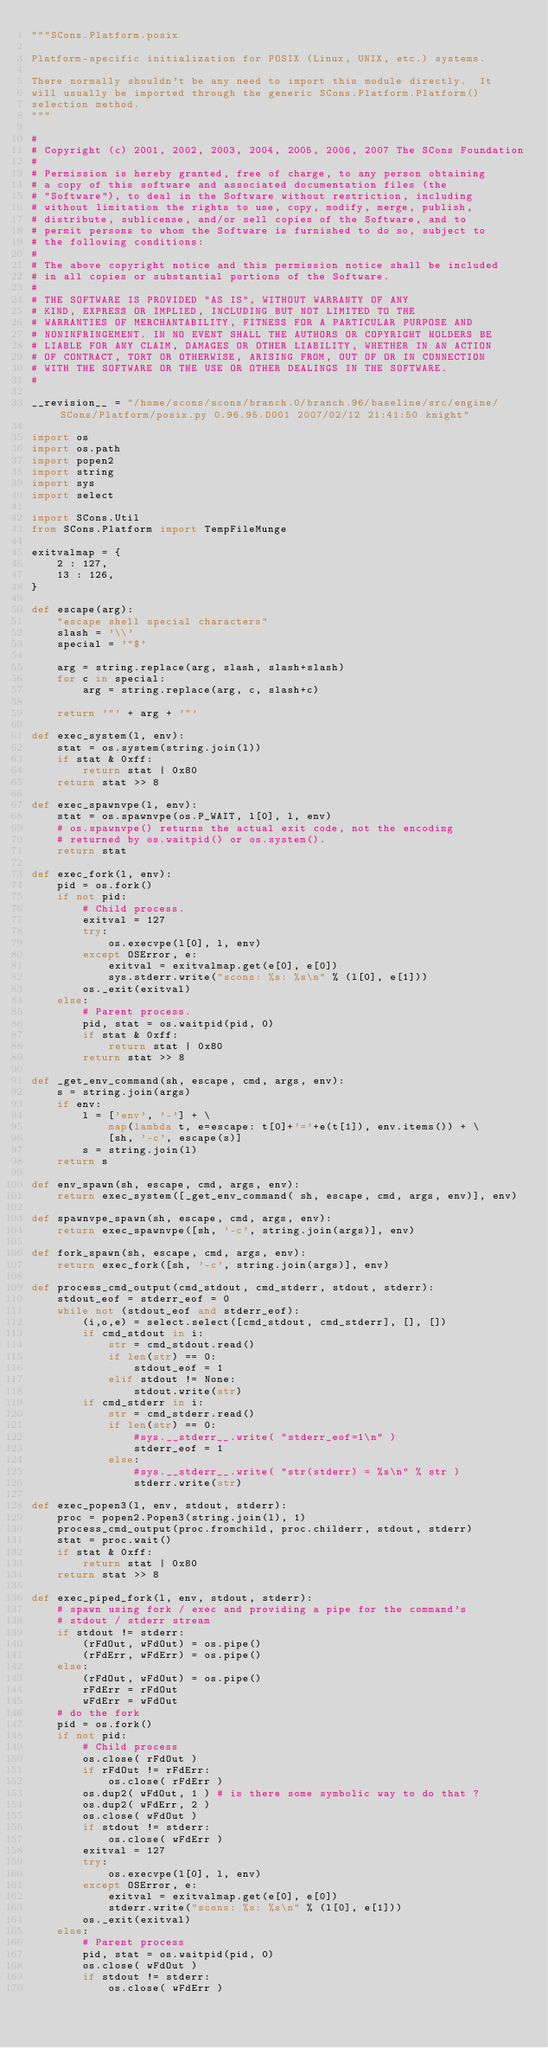<code> <loc_0><loc_0><loc_500><loc_500><_Python_>"""SCons.Platform.posix

Platform-specific initialization for POSIX (Linux, UNIX, etc.) systems.

There normally shouldn't be any need to import this module directly.  It
will usually be imported through the generic SCons.Platform.Platform()
selection method.
"""

#
# Copyright (c) 2001, 2002, 2003, 2004, 2005, 2006, 2007 The SCons Foundation
#
# Permission is hereby granted, free of charge, to any person obtaining
# a copy of this software and associated documentation files (the
# "Software"), to deal in the Software without restriction, including
# without limitation the rights to use, copy, modify, merge, publish,
# distribute, sublicense, and/or sell copies of the Software, and to
# permit persons to whom the Software is furnished to do so, subject to
# the following conditions:
#
# The above copyright notice and this permission notice shall be included
# in all copies or substantial portions of the Software.
#
# THE SOFTWARE IS PROVIDED "AS IS", WITHOUT WARRANTY OF ANY
# KIND, EXPRESS OR IMPLIED, INCLUDING BUT NOT LIMITED TO THE
# WARRANTIES OF MERCHANTABILITY, FITNESS FOR A PARTICULAR PURPOSE AND
# NONINFRINGEMENT. IN NO EVENT SHALL THE AUTHORS OR COPYRIGHT HOLDERS BE
# LIABLE FOR ANY CLAIM, DAMAGES OR OTHER LIABILITY, WHETHER IN AN ACTION
# OF CONTRACT, TORT OR OTHERWISE, ARISING FROM, OUT OF OR IN CONNECTION
# WITH THE SOFTWARE OR THE USE OR OTHER DEALINGS IN THE SOFTWARE.
#

__revision__ = "/home/scons/scons/branch.0/branch.96/baseline/src/engine/SCons/Platform/posix.py 0.96.95.D001 2007/02/12 21:41:50 knight"

import os
import os.path
import popen2
import string
import sys
import select

import SCons.Util
from SCons.Platform import TempFileMunge

exitvalmap = {
    2 : 127,
    13 : 126,
}

def escape(arg):
    "escape shell special characters"
    slash = '\\'
    special = '"$'

    arg = string.replace(arg, slash, slash+slash)
    for c in special:
        arg = string.replace(arg, c, slash+c)

    return '"' + arg + '"'

def exec_system(l, env):
    stat = os.system(string.join(l))
    if stat & 0xff:
        return stat | 0x80
    return stat >> 8

def exec_spawnvpe(l, env):
    stat = os.spawnvpe(os.P_WAIT, l[0], l, env)
    # os.spawnvpe() returns the actual exit code, not the encoding
    # returned by os.waitpid() or os.system().
    return stat

def exec_fork(l, env): 
    pid = os.fork()
    if not pid:
        # Child process.
        exitval = 127
        try:
            os.execvpe(l[0], l, env)
        except OSError, e:
            exitval = exitvalmap.get(e[0], e[0])
            sys.stderr.write("scons: %s: %s\n" % (l[0], e[1]))
        os._exit(exitval)
    else:
        # Parent process.
        pid, stat = os.waitpid(pid, 0)
        if stat & 0xff:
            return stat | 0x80
        return stat >> 8

def _get_env_command(sh, escape, cmd, args, env):
    s = string.join(args)
    if env:
        l = ['env', '-'] + \
            map(lambda t, e=escape: t[0]+'='+e(t[1]), env.items()) + \
            [sh, '-c', escape(s)]
        s = string.join(l)
    return s

def env_spawn(sh, escape, cmd, args, env):
    return exec_system([_get_env_command( sh, escape, cmd, args, env)], env)

def spawnvpe_spawn(sh, escape, cmd, args, env):
    return exec_spawnvpe([sh, '-c', string.join(args)], env)

def fork_spawn(sh, escape, cmd, args, env):
    return exec_fork([sh, '-c', string.join(args)], env)

def process_cmd_output(cmd_stdout, cmd_stderr, stdout, stderr):
    stdout_eof = stderr_eof = 0
    while not (stdout_eof and stderr_eof):
        (i,o,e) = select.select([cmd_stdout, cmd_stderr], [], [])
        if cmd_stdout in i:
            str = cmd_stdout.read()
            if len(str) == 0:
                stdout_eof = 1
            elif stdout != None:
                stdout.write(str)
        if cmd_stderr in i:
            str = cmd_stderr.read()
            if len(str) == 0:
                #sys.__stderr__.write( "stderr_eof=1\n" )
                stderr_eof = 1
            else:
                #sys.__stderr__.write( "str(stderr) = %s\n" % str )
                stderr.write(str)

def exec_popen3(l, env, stdout, stderr):
    proc = popen2.Popen3(string.join(l), 1)
    process_cmd_output(proc.fromchild, proc.childerr, stdout, stderr)
    stat = proc.wait()
    if stat & 0xff:
        return stat | 0x80
    return stat >> 8

def exec_piped_fork(l, env, stdout, stderr):
    # spawn using fork / exec and providing a pipe for the command's
    # stdout / stderr stream
    if stdout != stderr:
        (rFdOut, wFdOut) = os.pipe()
        (rFdErr, wFdErr) = os.pipe()
    else:
        (rFdOut, wFdOut) = os.pipe()
        rFdErr = rFdOut
        wFdErr = wFdOut
    # do the fork
    pid = os.fork()
    if not pid:
        # Child process
        os.close( rFdOut )
        if rFdOut != rFdErr:
            os.close( rFdErr )
        os.dup2( wFdOut, 1 ) # is there some symbolic way to do that ?
        os.dup2( wFdErr, 2 )
        os.close( wFdOut )
        if stdout != stderr:
            os.close( wFdErr )
        exitval = 127
        try:
            os.execvpe(l[0], l, env)
        except OSError, e:
            exitval = exitvalmap.get(e[0], e[0])
            stderr.write("scons: %s: %s\n" % (l[0], e[1]))
        os._exit(exitval)
    else:
        # Parent process
        pid, stat = os.waitpid(pid, 0)
        os.close( wFdOut )
        if stdout != stderr:
            os.close( wFdErr )</code> 